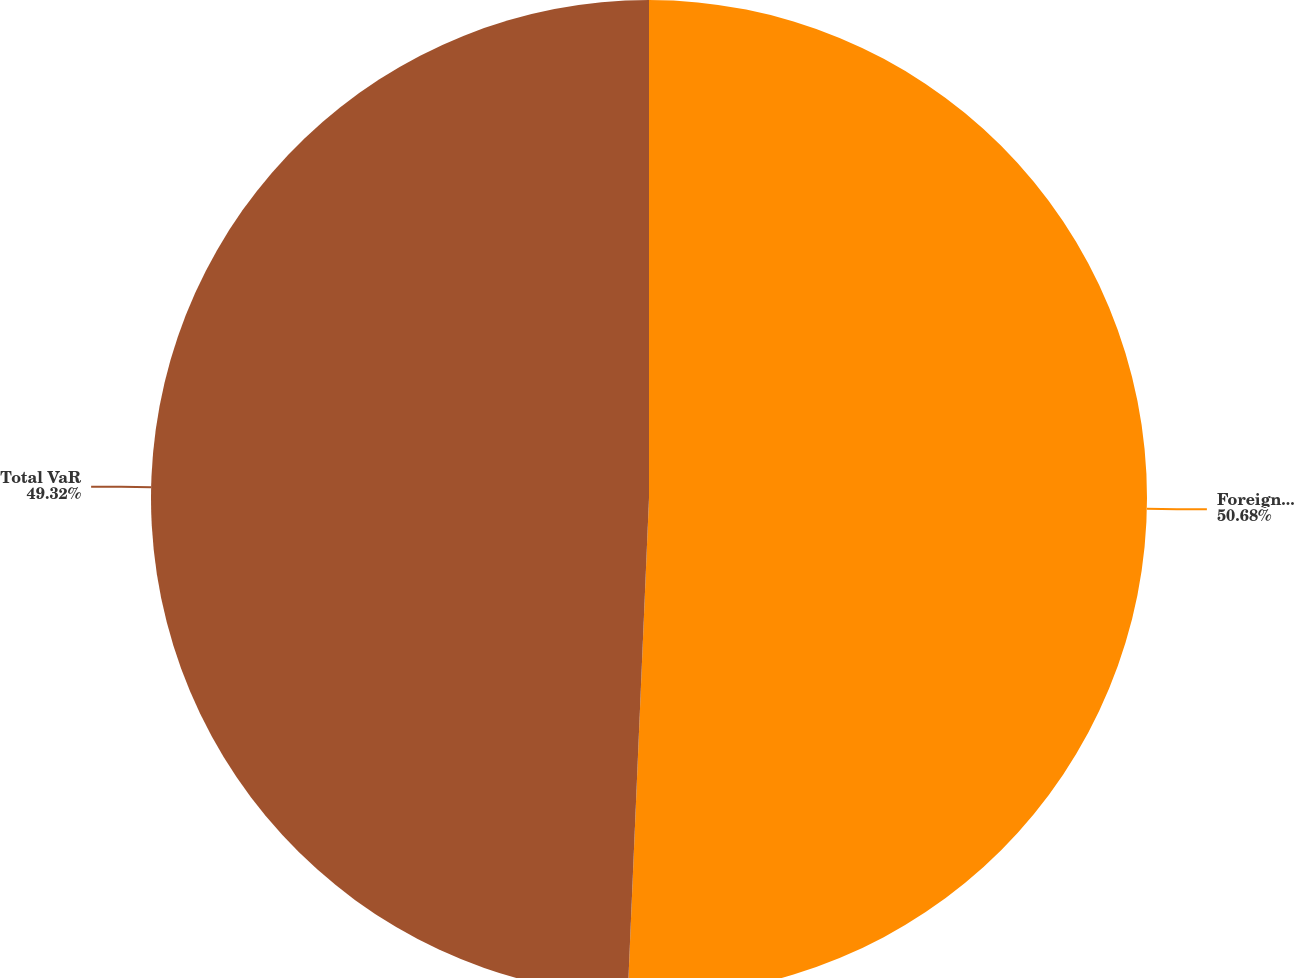Convert chart. <chart><loc_0><loc_0><loc_500><loc_500><pie_chart><fcel>Foreign exchange/Global<fcel>Total VaR<nl><fcel>50.68%<fcel>49.32%<nl></chart> 